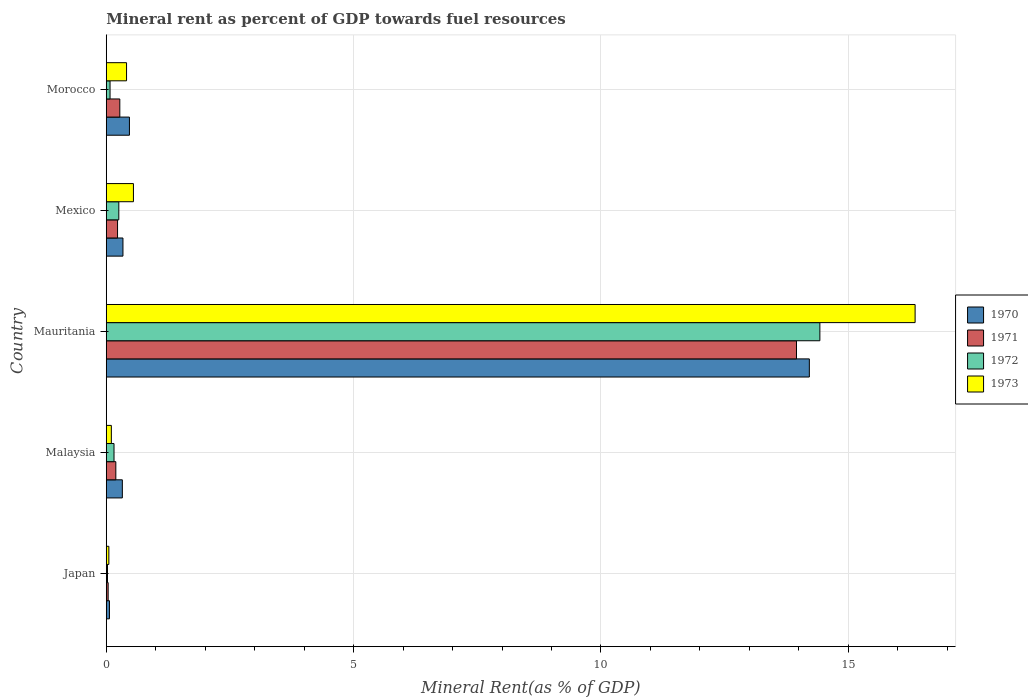How many different coloured bars are there?
Provide a short and direct response. 4. Are the number of bars per tick equal to the number of legend labels?
Ensure brevity in your answer.  Yes. How many bars are there on the 1st tick from the bottom?
Offer a terse response. 4. What is the mineral rent in 1972 in Morocco?
Ensure brevity in your answer.  0.08. Across all countries, what is the maximum mineral rent in 1970?
Provide a succinct answer. 14.21. Across all countries, what is the minimum mineral rent in 1970?
Keep it short and to the point. 0.06. In which country was the mineral rent in 1971 maximum?
Your response must be concise. Mauritania. In which country was the mineral rent in 1970 minimum?
Give a very brief answer. Japan. What is the total mineral rent in 1970 in the graph?
Your response must be concise. 15.41. What is the difference between the mineral rent in 1972 in Japan and that in Mexico?
Offer a very short reply. -0.23. What is the difference between the mineral rent in 1970 in Malaysia and the mineral rent in 1973 in Mauritania?
Make the answer very short. -16.03. What is the average mineral rent in 1972 per country?
Your answer should be compact. 2.99. What is the difference between the mineral rent in 1971 and mineral rent in 1973 in Mauritania?
Keep it short and to the point. -2.4. What is the ratio of the mineral rent in 1972 in Malaysia to that in Morocco?
Your answer should be very brief. 2.05. Is the mineral rent in 1972 in Malaysia less than that in Mauritania?
Your answer should be very brief. Yes. What is the difference between the highest and the second highest mineral rent in 1972?
Offer a very short reply. 14.17. What is the difference between the highest and the lowest mineral rent in 1970?
Make the answer very short. 14.15. Is the sum of the mineral rent in 1970 in Malaysia and Morocco greater than the maximum mineral rent in 1972 across all countries?
Provide a succinct answer. No. Is it the case that in every country, the sum of the mineral rent in 1970 and mineral rent in 1971 is greater than the sum of mineral rent in 1972 and mineral rent in 1973?
Your answer should be compact. No. What does the 4th bar from the bottom in Morocco represents?
Provide a short and direct response. 1973. Is it the case that in every country, the sum of the mineral rent in 1973 and mineral rent in 1970 is greater than the mineral rent in 1971?
Make the answer very short. Yes. How many bars are there?
Provide a short and direct response. 20. What is the difference between two consecutive major ticks on the X-axis?
Provide a short and direct response. 5. Are the values on the major ticks of X-axis written in scientific E-notation?
Make the answer very short. No. Does the graph contain any zero values?
Your response must be concise. No. Does the graph contain grids?
Ensure brevity in your answer.  Yes. Where does the legend appear in the graph?
Your response must be concise. Center right. How many legend labels are there?
Provide a succinct answer. 4. How are the legend labels stacked?
Offer a very short reply. Vertical. What is the title of the graph?
Provide a short and direct response. Mineral rent as percent of GDP towards fuel resources. What is the label or title of the X-axis?
Ensure brevity in your answer.  Mineral Rent(as % of GDP). What is the label or title of the Y-axis?
Your answer should be very brief. Country. What is the Mineral Rent(as % of GDP) of 1970 in Japan?
Offer a terse response. 0.06. What is the Mineral Rent(as % of GDP) in 1971 in Japan?
Your answer should be very brief. 0.04. What is the Mineral Rent(as % of GDP) in 1972 in Japan?
Make the answer very short. 0.03. What is the Mineral Rent(as % of GDP) in 1973 in Japan?
Offer a very short reply. 0.05. What is the Mineral Rent(as % of GDP) in 1970 in Malaysia?
Provide a short and direct response. 0.33. What is the Mineral Rent(as % of GDP) in 1971 in Malaysia?
Give a very brief answer. 0.19. What is the Mineral Rent(as % of GDP) of 1972 in Malaysia?
Give a very brief answer. 0.16. What is the Mineral Rent(as % of GDP) of 1973 in Malaysia?
Your answer should be very brief. 0.1. What is the Mineral Rent(as % of GDP) in 1970 in Mauritania?
Keep it short and to the point. 14.21. What is the Mineral Rent(as % of GDP) of 1971 in Mauritania?
Offer a terse response. 13.95. What is the Mineral Rent(as % of GDP) of 1972 in Mauritania?
Provide a succinct answer. 14.43. What is the Mineral Rent(as % of GDP) in 1973 in Mauritania?
Your answer should be very brief. 16.35. What is the Mineral Rent(as % of GDP) of 1970 in Mexico?
Your answer should be compact. 0.34. What is the Mineral Rent(as % of GDP) in 1971 in Mexico?
Offer a very short reply. 0.23. What is the Mineral Rent(as % of GDP) in 1972 in Mexico?
Your response must be concise. 0.25. What is the Mineral Rent(as % of GDP) of 1973 in Mexico?
Ensure brevity in your answer.  0.55. What is the Mineral Rent(as % of GDP) in 1970 in Morocco?
Your response must be concise. 0.47. What is the Mineral Rent(as % of GDP) in 1971 in Morocco?
Keep it short and to the point. 0.27. What is the Mineral Rent(as % of GDP) of 1972 in Morocco?
Offer a very short reply. 0.08. What is the Mineral Rent(as % of GDP) in 1973 in Morocco?
Your response must be concise. 0.41. Across all countries, what is the maximum Mineral Rent(as % of GDP) of 1970?
Offer a terse response. 14.21. Across all countries, what is the maximum Mineral Rent(as % of GDP) in 1971?
Offer a very short reply. 13.95. Across all countries, what is the maximum Mineral Rent(as % of GDP) in 1972?
Keep it short and to the point. 14.43. Across all countries, what is the maximum Mineral Rent(as % of GDP) in 1973?
Give a very brief answer. 16.35. Across all countries, what is the minimum Mineral Rent(as % of GDP) of 1970?
Offer a terse response. 0.06. Across all countries, what is the minimum Mineral Rent(as % of GDP) in 1971?
Ensure brevity in your answer.  0.04. Across all countries, what is the minimum Mineral Rent(as % of GDP) of 1972?
Your answer should be compact. 0.03. Across all countries, what is the minimum Mineral Rent(as % of GDP) of 1973?
Ensure brevity in your answer.  0.05. What is the total Mineral Rent(as % of GDP) in 1970 in the graph?
Make the answer very short. 15.41. What is the total Mineral Rent(as % of GDP) of 1971 in the graph?
Your answer should be very brief. 14.69. What is the total Mineral Rent(as % of GDP) of 1972 in the graph?
Provide a succinct answer. 14.94. What is the total Mineral Rent(as % of GDP) of 1973 in the graph?
Ensure brevity in your answer.  17.47. What is the difference between the Mineral Rent(as % of GDP) of 1970 in Japan and that in Malaysia?
Offer a terse response. -0.26. What is the difference between the Mineral Rent(as % of GDP) in 1971 in Japan and that in Malaysia?
Provide a short and direct response. -0.16. What is the difference between the Mineral Rent(as % of GDP) in 1972 in Japan and that in Malaysia?
Your answer should be compact. -0.13. What is the difference between the Mineral Rent(as % of GDP) in 1973 in Japan and that in Malaysia?
Give a very brief answer. -0.05. What is the difference between the Mineral Rent(as % of GDP) in 1970 in Japan and that in Mauritania?
Offer a very short reply. -14.15. What is the difference between the Mineral Rent(as % of GDP) of 1971 in Japan and that in Mauritania?
Provide a short and direct response. -13.91. What is the difference between the Mineral Rent(as % of GDP) of 1972 in Japan and that in Mauritania?
Offer a very short reply. -14.4. What is the difference between the Mineral Rent(as % of GDP) in 1973 in Japan and that in Mauritania?
Your response must be concise. -16.3. What is the difference between the Mineral Rent(as % of GDP) of 1970 in Japan and that in Mexico?
Give a very brief answer. -0.27. What is the difference between the Mineral Rent(as % of GDP) in 1971 in Japan and that in Mexico?
Give a very brief answer. -0.19. What is the difference between the Mineral Rent(as % of GDP) of 1972 in Japan and that in Mexico?
Make the answer very short. -0.23. What is the difference between the Mineral Rent(as % of GDP) in 1973 in Japan and that in Mexico?
Your answer should be compact. -0.5. What is the difference between the Mineral Rent(as % of GDP) in 1970 in Japan and that in Morocco?
Provide a succinct answer. -0.4. What is the difference between the Mineral Rent(as % of GDP) in 1971 in Japan and that in Morocco?
Your answer should be very brief. -0.24. What is the difference between the Mineral Rent(as % of GDP) of 1972 in Japan and that in Morocco?
Keep it short and to the point. -0.05. What is the difference between the Mineral Rent(as % of GDP) in 1973 in Japan and that in Morocco?
Offer a terse response. -0.36. What is the difference between the Mineral Rent(as % of GDP) of 1970 in Malaysia and that in Mauritania?
Your answer should be compact. -13.89. What is the difference between the Mineral Rent(as % of GDP) in 1971 in Malaysia and that in Mauritania?
Provide a succinct answer. -13.76. What is the difference between the Mineral Rent(as % of GDP) in 1972 in Malaysia and that in Mauritania?
Offer a terse response. -14.27. What is the difference between the Mineral Rent(as % of GDP) in 1973 in Malaysia and that in Mauritania?
Offer a very short reply. -16.25. What is the difference between the Mineral Rent(as % of GDP) in 1970 in Malaysia and that in Mexico?
Your answer should be compact. -0.01. What is the difference between the Mineral Rent(as % of GDP) in 1971 in Malaysia and that in Mexico?
Give a very brief answer. -0.03. What is the difference between the Mineral Rent(as % of GDP) in 1972 in Malaysia and that in Mexico?
Offer a very short reply. -0.1. What is the difference between the Mineral Rent(as % of GDP) of 1973 in Malaysia and that in Mexico?
Provide a short and direct response. -0.45. What is the difference between the Mineral Rent(as % of GDP) in 1970 in Malaysia and that in Morocco?
Keep it short and to the point. -0.14. What is the difference between the Mineral Rent(as % of GDP) in 1971 in Malaysia and that in Morocco?
Ensure brevity in your answer.  -0.08. What is the difference between the Mineral Rent(as % of GDP) in 1972 in Malaysia and that in Morocco?
Your answer should be very brief. 0.08. What is the difference between the Mineral Rent(as % of GDP) in 1973 in Malaysia and that in Morocco?
Offer a terse response. -0.31. What is the difference between the Mineral Rent(as % of GDP) in 1970 in Mauritania and that in Mexico?
Your answer should be very brief. 13.88. What is the difference between the Mineral Rent(as % of GDP) of 1971 in Mauritania and that in Mexico?
Your answer should be compact. 13.72. What is the difference between the Mineral Rent(as % of GDP) of 1972 in Mauritania and that in Mexico?
Make the answer very short. 14.17. What is the difference between the Mineral Rent(as % of GDP) in 1973 in Mauritania and that in Mexico?
Offer a very short reply. 15.8. What is the difference between the Mineral Rent(as % of GDP) of 1970 in Mauritania and that in Morocco?
Your answer should be compact. 13.74. What is the difference between the Mineral Rent(as % of GDP) in 1971 in Mauritania and that in Morocco?
Provide a short and direct response. 13.68. What is the difference between the Mineral Rent(as % of GDP) in 1972 in Mauritania and that in Morocco?
Your answer should be compact. 14.35. What is the difference between the Mineral Rent(as % of GDP) of 1973 in Mauritania and that in Morocco?
Your response must be concise. 15.94. What is the difference between the Mineral Rent(as % of GDP) of 1970 in Mexico and that in Morocco?
Offer a very short reply. -0.13. What is the difference between the Mineral Rent(as % of GDP) of 1971 in Mexico and that in Morocco?
Your response must be concise. -0.05. What is the difference between the Mineral Rent(as % of GDP) of 1972 in Mexico and that in Morocco?
Provide a succinct answer. 0.18. What is the difference between the Mineral Rent(as % of GDP) in 1973 in Mexico and that in Morocco?
Keep it short and to the point. 0.14. What is the difference between the Mineral Rent(as % of GDP) in 1970 in Japan and the Mineral Rent(as % of GDP) in 1971 in Malaysia?
Provide a short and direct response. -0.13. What is the difference between the Mineral Rent(as % of GDP) in 1970 in Japan and the Mineral Rent(as % of GDP) in 1972 in Malaysia?
Offer a very short reply. -0.09. What is the difference between the Mineral Rent(as % of GDP) in 1970 in Japan and the Mineral Rent(as % of GDP) in 1973 in Malaysia?
Give a very brief answer. -0.04. What is the difference between the Mineral Rent(as % of GDP) of 1971 in Japan and the Mineral Rent(as % of GDP) of 1972 in Malaysia?
Provide a short and direct response. -0.12. What is the difference between the Mineral Rent(as % of GDP) of 1971 in Japan and the Mineral Rent(as % of GDP) of 1973 in Malaysia?
Ensure brevity in your answer.  -0.06. What is the difference between the Mineral Rent(as % of GDP) of 1972 in Japan and the Mineral Rent(as % of GDP) of 1973 in Malaysia?
Ensure brevity in your answer.  -0.08. What is the difference between the Mineral Rent(as % of GDP) in 1970 in Japan and the Mineral Rent(as % of GDP) in 1971 in Mauritania?
Give a very brief answer. -13.89. What is the difference between the Mineral Rent(as % of GDP) of 1970 in Japan and the Mineral Rent(as % of GDP) of 1972 in Mauritania?
Your response must be concise. -14.36. What is the difference between the Mineral Rent(as % of GDP) of 1970 in Japan and the Mineral Rent(as % of GDP) of 1973 in Mauritania?
Keep it short and to the point. -16.29. What is the difference between the Mineral Rent(as % of GDP) of 1971 in Japan and the Mineral Rent(as % of GDP) of 1972 in Mauritania?
Your response must be concise. -14.39. What is the difference between the Mineral Rent(as % of GDP) of 1971 in Japan and the Mineral Rent(as % of GDP) of 1973 in Mauritania?
Your answer should be compact. -16.31. What is the difference between the Mineral Rent(as % of GDP) in 1972 in Japan and the Mineral Rent(as % of GDP) in 1973 in Mauritania?
Your answer should be compact. -16.33. What is the difference between the Mineral Rent(as % of GDP) in 1970 in Japan and the Mineral Rent(as % of GDP) in 1971 in Mexico?
Provide a short and direct response. -0.16. What is the difference between the Mineral Rent(as % of GDP) of 1970 in Japan and the Mineral Rent(as % of GDP) of 1972 in Mexico?
Offer a very short reply. -0.19. What is the difference between the Mineral Rent(as % of GDP) of 1970 in Japan and the Mineral Rent(as % of GDP) of 1973 in Mexico?
Provide a short and direct response. -0.48. What is the difference between the Mineral Rent(as % of GDP) in 1971 in Japan and the Mineral Rent(as % of GDP) in 1972 in Mexico?
Your answer should be compact. -0.22. What is the difference between the Mineral Rent(as % of GDP) in 1971 in Japan and the Mineral Rent(as % of GDP) in 1973 in Mexico?
Your answer should be very brief. -0.51. What is the difference between the Mineral Rent(as % of GDP) in 1972 in Japan and the Mineral Rent(as % of GDP) in 1973 in Mexico?
Provide a short and direct response. -0.52. What is the difference between the Mineral Rent(as % of GDP) in 1970 in Japan and the Mineral Rent(as % of GDP) in 1971 in Morocco?
Offer a terse response. -0.21. What is the difference between the Mineral Rent(as % of GDP) in 1970 in Japan and the Mineral Rent(as % of GDP) in 1972 in Morocco?
Provide a short and direct response. -0.01. What is the difference between the Mineral Rent(as % of GDP) of 1970 in Japan and the Mineral Rent(as % of GDP) of 1973 in Morocco?
Keep it short and to the point. -0.35. What is the difference between the Mineral Rent(as % of GDP) of 1971 in Japan and the Mineral Rent(as % of GDP) of 1972 in Morocco?
Your answer should be compact. -0.04. What is the difference between the Mineral Rent(as % of GDP) of 1971 in Japan and the Mineral Rent(as % of GDP) of 1973 in Morocco?
Offer a very short reply. -0.37. What is the difference between the Mineral Rent(as % of GDP) in 1972 in Japan and the Mineral Rent(as % of GDP) in 1973 in Morocco?
Your answer should be compact. -0.39. What is the difference between the Mineral Rent(as % of GDP) in 1970 in Malaysia and the Mineral Rent(as % of GDP) in 1971 in Mauritania?
Offer a terse response. -13.63. What is the difference between the Mineral Rent(as % of GDP) of 1970 in Malaysia and the Mineral Rent(as % of GDP) of 1972 in Mauritania?
Your response must be concise. -14.1. What is the difference between the Mineral Rent(as % of GDP) in 1970 in Malaysia and the Mineral Rent(as % of GDP) in 1973 in Mauritania?
Provide a succinct answer. -16.03. What is the difference between the Mineral Rent(as % of GDP) in 1971 in Malaysia and the Mineral Rent(as % of GDP) in 1972 in Mauritania?
Your response must be concise. -14.23. What is the difference between the Mineral Rent(as % of GDP) of 1971 in Malaysia and the Mineral Rent(as % of GDP) of 1973 in Mauritania?
Your response must be concise. -16.16. What is the difference between the Mineral Rent(as % of GDP) of 1972 in Malaysia and the Mineral Rent(as % of GDP) of 1973 in Mauritania?
Provide a short and direct response. -16.19. What is the difference between the Mineral Rent(as % of GDP) in 1970 in Malaysia and the Mineral Rent(as % of GDP) in 1971 in Mexico?
Your answer should be very brief. 0.1. What is the difference between the Mineral Rent(as % of GDP) in 1970 in Malaysia and the Mineral Rent(as % of GDP) in 1972 in Mexico?
Make the answer very short. 0.07. What is the difference between the Mineral Rent(as % of GDP) of 1970 in Malaysia and the Mineral Rent(as % of GDP) of 1973 in Mexico?
Your answer should be very brief. -0.22. What is the difference between the Mineral Rent(as % of GDP) of 1971 in Malaysia and the Mineral Rent(as % of GDP) of 1972 in Mexico?
Keep it short and to the point. -0.06. What is the difference between the Mineral Rent(as % of GDP) of 1971 in Malaysia and the Mineral Rent(as % of GDP) of 1973 in Mexico?
Offer a very short reply. -0.36. What is the difference between the Mineral Rent(as % of GDP) in 1972 in Malaysia and the Mineral Rent(as % of GDP) in 1973 in Mexico?
Give a very brief answer. -0.39. What is the difference between the Mineral Rent(as % of GDP) of 1970 in Malaysia and the Mineral Rent(as % of GDP) of 1971 in Morocco?
Offer a very short reply. 0.05. What is the difference between the Mineral Rent(as % of GDP) of 1970 in Malaysia and the Mineral Rent(as % of GDP) of 1972 in Morocco?
Make the answer very short. 0.25. What is the difference between the Mineral Rent(as % of GDP) in 1970 in Malaysia and the Mineral Rent(as % of GDP) in 1973 in Morocco?
Provide a short and direct response. -0.09. What is the difference between the Mineral Rent(as % of GDP) in 1971 in Malaysia and the Mineral Rent(as % of GDP) in 1972 in Morocco?
Offer a very short reply. 0.12. What is the difference between the Mineral Rent(as % of GDP) in 1971 in Malaysia and the Mineral Rent(as % of GDP) in 1973 in Morocco?
Ensure brevity in your answer.  -0.22. What is the difference between the Mineral Rent(as % of GDP) in 1972 in Malaysia and the Mineral Rent(as % of GDP) in 1973 in Morocco?
Offer a very short reply. -0.25. What is the difference between the Mineral Rent(as % of GDP) of 1970 in Mauritania and the Mineral Rent(as % of GDP) of 1971 in Mexico?
Provide a succinct answer. 13.98. What is the difference between the Mineral Rent(as % of GDP) of 1970 in Mauritania and the Mineral Rent(as % of GDP) of 1972 in Mexico?
Offer a very short reply. 13.96. What is the difference between the Mineral Rent(as % of GDP) in 1970 in Mauritania and the Mineral Rent(as % of GDP) in 1973 in Mexico?
Keep it short and to the point. 13.66. What is the difference between the Mineral Rent(as % of GDP) of 1971 in Mauritania and the Mineral Rent(as % of GDP) of 1972 in Mexico?
Your answer should be very brief. 13.7. What is the difference between the Mineral Rent(as % of GDP) in 1971 in Mauritania and the Mineral Rent(as % of GDP) in 1973 in Mexico?
Ensure brevity in your answer.  13.4. What is the difference between the Mineral Rent(as % of GDP) in 1972 in Mauritania and the Mineral Rent(as % of GDP) in 1973 in Mexico?
Keep it short and to the point. 13.88. What is the difference between the Mineral Rent(as % of GDP) of 1970 in Mauritania and the Mineral Rent(as % of GDP) of 1971 in Morocco?
Provide a short and direct response. 13.94. What is the difference between the Mineral Rent(as % of GDP) of 1970 in Mauritania and the Mineral Rent(as % of GDP) of 1972 in Morocco?
Offer a very short reply. 14.14. What is the difference between the Mineral Rent(as % of GDP) of 1970 in Mauritania and the Mineral Rent(as % of GDP) of 1973 in Morocco?
Make the answer very short. 13.8. What is the difference between the Mineral Rent(as % of GDP) of 1971 in Mauritania and the Mineral Rent(as % of GDP) of 1972 in Morocco?
Make the answer very short. 13.88. What is the difference between the Mineral Rent(as % of GDP) in 1971 in Mauritania and the Mineral Rent(as % of GDP) in 1973 in Morocco?
Give a very brief answer. 13.54. What is the difference between the Mineral Rent(as % of GDP) in 1972 in Mauritania and the Mineral Rent(as % of GDP) in 1973 in Morocco?
Give a very brief answer. 14.02. What is the difference between the Mineral Rent(as % of GDP) of 1970 in Mexico and the Mineral Rent(as % of GDP) of 1971 in Morocco?
Offer a very short reply. 0.06. What is the difference between the Mineral Rent(as % of GDP) of 1970 in Mexico and the Mineral Rent(as % of GDP) of 1972 in Morocco?
Give a very brief answer. 0.26. What is the difference between the Mineral Rent(as % of GDP) in 1970 in Mexico and the Mineral Rent(as % of GDP) in 1973 in Morocco?
Offer a very short reply. -0.07. What is the difference between the Mineral Rent(as % of GDP) of 1971 in Mexico and the Mineral Rent(as % of GDP) of 1972 in Morocco?
Offer a very short reply. 0.15. What is the difference between the Mineral Rent(as % of GDP) of 1971 in Mexico and the Mineral Rent(as % of GDP) of 1973 in Morocco?
Your answer should be compact. -0.18. What is the difference between the Mineral Rent(as % of GDP) of 1972 in Mexico and the Mineral Rent(as % of GDP) of 1973 in Morocco?
Your answer should be very brief. -0.16. What is the average Mineral Rent(as % of GDP) in 1970 per country?
Offer a very short reply. 3.08. What is the average Mineral Rent(as % of GDP) of 1971 per country?
Your response must be concise. 2.94. What is the average Mineral Rent(as % of GDP) in 1972 per country?
Provide a short and direct response. 2.99. What is the average Mineral Rent(as % of GDP) of 1973 per country?
Give a very brief answer. 3.49. What is the difference between the Mineral Rent(as % of GDP) of 1970 and Mineral Rent(as % of GDP) of 1971 in Japan?
Give a very brief answer. 0.03. What is the difference between the Mineral Rent(as % of GDP) of 1970 and Mineral Rent(as % of GDP) of 1972 in Japan?
Give a very brief answer. 0.04. What is the difference between the Mineral Rent(as % of GDP) in 1970 and Mineral Rent(as % of GDP) in 1973 in Japan?
Provide a succinct answer. 0.01. What is the difference between the Mineral Rent(as % of GDP) of 1971 and Mineral Rent(as % of GDP) of 1972 in Japan?
Provide a short and direct response. 0.01. What is the difference between the Mineral Rent(as % of GDP) of 1971 and Mineral Rent(as % of GDP) of 1973 in Japan?
Provide a succinct answer. -0.01. What is the difference between the Mineral Rent(as % of GDP) in 1972 and Mineral Rent(as % of GDP) in 1973 in Japan?
Your answer should be compact. -0.03. What is the difference between the Mineral Rent(as % of GDP) of 1970 and Mineral Rent(as % of GDP) of 1971 in Malaysia?
Offer a very short reply. 0.13. What is the difference between the Mineral Rent(as % of GDP) in 1970 and Mineral Rent(as % of GDP) in 1972 in Malaysia?
Ensure brevity in your answer.  0.17. What is the difference between the Mineral Rent(as % of GDP) of 1970 and Mineral Rent(as % of GDP) of 1973 in Malaysia?
Ensure brevity in your answer.  0.22. What is the difference between the Mineral Rent(as % of GDP) of 1971 and Mineral Rent(as % of GDP) of 1972 in Malaysia?
Provide a succinct answer. 0.04. What is the difference between the Mineral Rent(as % of GDP) in 1971 and Mineral Rent(as % of GDP) in 1973 in Malaysia?
Offer a very short reply. 0.09. What is the difference between the Mineral Rent(as % of GDP) in 1972 and Mineral Rent(as % of GDP) in 1973 in Malaysia?
Keep it short and to the point. 0.05. What is the difference between the Mineral Rent(as % of GDP) of 1970 and Mineral Rent(as % of GDP) of 1971 in Mauritania?
Your answer should be very brief. 0.26. What is the difference between the Mineral Rent(as % of GDP) of 1970 and Mineral Rent(as % of GDP) of 1972 in Mauritania?
Your response must be concise. -0.21. What is the difference between the Mineral Rent(as % of GDP) of 1970 and Mineral Rent(as % of GDP) of 1973 in Mauritania?
Offer a terse response. -2.14. What is the difference between the Mineral Rent(as % of GDP) of 1971 and Mineral Rent(as % of GDP) of 1972 in Mauritania?
Ensure brevity in your answer.  -0.47. What is the difference between the Mineral Rent(as % of GDP) in 1971 and Mineral Rent(as % of GDP) in 1973 in Mauritania?
Keep it short and to the point. -2.4. What is the difference between the Mineral Rent(as % of GDP) in 1972 and Mineral Rent(as % of GDP) in 1973 in Mauritania?
Keep it short and to the point. -1.93. What is the difference between the Mineral Rent(as % of GDP) of 1970 and Mineral Rent(as % of GDP) of 1971 in Mexico?
Your answer should be very brief. 0.11. What is the difference between the Mineral Rent(as % of GDP) of 1970 and Mineral Rent(as % of GDP) of 1972 in Mexico?
Your answer should be compact. 0.08. What is the difference between the Mineral Rent(as % of GDP) of 1970 and Mineral Rent(as % of GDP) of 1973 in Mexico?
Provide a short and direct response. -0.21. What is the difference between the Mineral Rent(as % of GDP) in 1971 and Mineral Rent(as % of GDP) in 1972 in Mexico?
Provide a succinct answer. -0.03. What is the difference between the Mineral Rent(as % of GDP) of 1971 and Mineral Rent(as % of GDP) of 1973 in Mexico?
Your response must be concise. -0.32. What is the difference between the Mineral Rent(as % of GDP) in 1972 and Mineral Rent(as % of GDP) in 1973 in Mexico?
Ensure brevity in your answer.  -0.3. What is the difference between the Mineral Rent(as % of GDP) in 1970 and Mineral Rent(as % of GDP) in 1971 in Morocco?
Keep it short and to the point. 0.19. What is the difference between the Mineral Rent(as % of GDP) in 1970 and Mineral Rent(as % of GDP) in 1972 in Morocco?
Your response must be concise. 0.39. What is the difference between the Mineral Rent(as % of GDP) of 1970 and Mineral Rent(as % of GDP) of 1973 in Morocco?
Your answer should be very brief. 0.06. What is the difference between the Mineral Rent(as % of GDP) in 1971 and Mineral Rent(as % of GDP) in 1972 in Morocco?
Provide a short and direct response. 0.2. What is the difference between the Mineral Rent(as % of GDP) of 1971 and Mineral Rent(as % of GDP) of 1973 in Morocco?
Provide a short and direct response. -0.14. What is the difference between the Mineral Rent(as % of GDP) in 1972 and Mineral Rent(as % of GDP) in 1973 in Morocco?
Offer a very short reply. -0.33. What is the ratio of the Mineral Rent(as % of GDP) of 1970 in Japan to that in Malaysia?
Make the answer very short. 0.2. What is the ratio of the Mineral Rent(as % of GDP) in 1971 in Japan to that in Malaysia?
Offer a terse response. 0.2. What is the ratio of the Mineral Rent(as % of GDP) of 1972 in Japan to that in Malaysia?
Give a very brief answer. 0.16. What is the ratio of the Mineral Rent(as % of GDP) of 1973 in Japan to that in Malaysia?
Offer a very short reply. 0.51. What is the ratio of the Mineral Rent(as % of GDP) of 1970 in Japan to that in Mauritania?
Your answer should be very brief. 0. What is the ratio of the Mineral Rent(as % of GDP) in 1971 in Japan to that in Mauritania?
Your response must be concise. 0. What is the ratio of the Mineral Rent(as % of GDP) in 1972 in Japan to that in Mauritania?
Your response must be concise. 0. What is the ratio of the Mineral Rent(as % of GDP) of 1973 in Japan to that in Mauritania?
Your answer should be very brief. 0. What is the ratio of the Mineral Rent(as % of GDP) in 1970 in Japan to that in Mexico?
Make the answer very short. 0.19. What is the ratio of the Mineral Rent(as % of GDP) of 1971 in Japan to that in Mexico?
Provide a short and direct response. 0.17. What is the ratio of the Mineral Rent(as % of GDP) of 1972 in Japan to that in Mexico?
Keep it short and to the point. 0.1. What is the ratio of the Mineral Rent(as % of GDP) in 1973 in Japan to that in Mexico?
Give a very brief answer. 0.1. What is the ratio of the Mineral Rent(as % of GDP) of 1970 in Japan to that in Morocco?
Provide a succinct answer. 0.14. What is the ratio of the Mineral Rent(as % of GDP) of 1971 in Japan to that in Morocco?
Your answer should be very brief. 0.14. What is the ratio of the Mineral Rent(as % of GDP) in 1972 in Japan to that in Morocco?
Ensure brevity in your answer.  0.33. What is the ratio of the Mineral Rent(as % of GDP) of 1973 in Japan to that in Morocco?
Ensure brevity in your answer.  0.13. What is the ratio of the Mineral Rent(as % of GDP) of 1970 in Malaysia to that in Mauritania?
Your answer should be compact. 0.02. What is the ratio of the Mineral Rent(as % of GDP) in 1971 in Malaysia to that in Mauritania?
Your answer should be compact. 0.01. What is the ratio of the Mineral Rent(as % of GDP) in 1972 in Malaysia to that in Mauritania?
Your answer should be compact. 0.01. What is the ratio of the Mineral Rent(as % of GDP) of 1973 in Malaysia to that in Mauritania?
Offer a very short reply. 0.01. What is the ratio of the Mineral Rent(as % of GDP) in 1970 in Malaysia to that in Mexico?
Offer a terse response. 0.96. What is the ratio of the Mineral Rent(as % of GDP) of 1971 in Malaysia to that in Mexico?
Keep it short and to the point. 0.85. What is the ratio of the Mineral Rent(as % of GDP) in 1972 in Malaysia to that in Mexico?
Make the answer very short. 0.62. What is the ratio of the Mineral Rent(as % of GDP) of 1973 in Malaysia to that in Mexico?
Give a very brief answer. 0.19. What is the ratio of the Mineral Rent(as % of GDP) of 1970 in Malaysia to that in Morocco?
Your answer should be very brief. 0.69. What is the ratio of the Mineral Rent(as % of GDP) in 1971 in Malaysia to that in Morocco?
Keep it short and to the point. 0.71. What is the ratio of the Mineral Rent(as % of GDP) in 1972 in Malaysia to that in Morocco?
Give a very brief answer. 2.04. What is the ratio of the Mineral Rent(as % of GDP) of 1973 in Malaysia to that in Morocco?
Provide a short and direct response. 0.25. What is the ratio of the Mineral Rent(as % of GDP) in 1970 in Mauritania to that in Mexico?
Give a very brief answer. 42.1. What is the ratio of the Mineral Rent(as % of GDP) of 1971 in Mauritania to that in Mexico?
Your answer should be very brief. 61.1. What is the ratio of the Mineral Rent(as % of GDP) of 1972 in Mauritania to that in Mexico?
Offer a terse response. 56.78. What is the ratio of the Mineral Rent(as % of GDP) of 1973 in Mauritania to that in Mexico?
Provide a short and direct response. 29.75. What is the ratio of the Mineral Rent(as % of GDP) of 1970 in Mauritania to that in Morocco?
Your answer should be compact. 30.32. What is the ratio of the Mineral Rent(as % of GDP) of 1971 in Mauritania to that in Morocco?
Give a very brief answer. 50.9. What is the ratio of the Mineral Rent(as % of GDP) in 1972 in Mauritania to that in Morocco?
Provide a short and direct response. 187.82. What is the ratio of the Mineral Rent(as % of GDP) of 1973 in Mauritania to that in Morocco?
Make the answer very short. 39.85. What is the ratio of the Mineral Rent(as % of GDP) in 1970 in Mexico to that in Morocco?
Your answer should be very brief. 0.72. What is the ratio of the Mineral Rent(as % of GDP) in 1971 in Mexico to that in Morocco?
Offer a very short reply. 0.83. What is the ratio of the Mineral Rent(as % of GDP) in 1972 in Mexico to that in Morocco?
Offer a terse response. 3.31. What is the ratio of the Mineral Rent(as % of GDP) in 1973 in Mexico to that in Morocco?
Provide a short and direct response. 1.34. What is the difference between the highest and the second highest Mineral Rent(as % of GDP) of 1970?
Your response must be concise. 13.74. What is the difference between the highest and the second highest Mineral Rent(as % of GDP) in 1971?
Your answer should be very brief. 13.68. What is the difference between the highest and the second highest Mineral Rent(as % of GDP) of 1972?
Offer a terse response. 14.17. What is the difference between the highest and the second highest Mineral Rent(as % of GDP) in 1973?
Your answer should be compact. 15.8. What is the difference between the highest and the lowest Mineral Rent(as % of GDP) of 1970?
Give a very brief answer. 14.15. What is the difference between the highest and the lowest Mineral Rent(as % of GDP) of 1971?
Keep it short and to the point. 13.91. What is the difference between the highest and the lowest Mineral Rent(as % of GDP) in 1972?
Your answer should be compact. 14.4. What is the difference between the highest and the lowest Mineral Rent(as % of GDP) of 1973?
Provide a short and direct response. 16.3. 